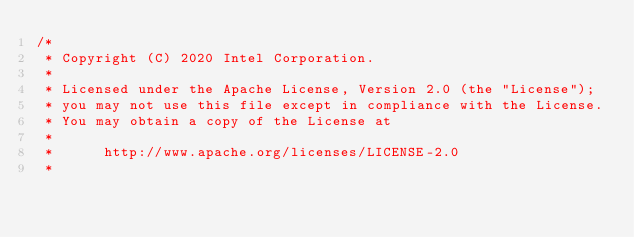<code> <loc_0><loc_0><loc_500><loc_500><_C_>/*
 * Copyright (C) 2020 Intel Corporation.
 *
 * Licensed under the Apache License, Version 2.0 (the "License");
 * you may not use this file except in compliance with the License.
 * You may obtain a copy of the License at
 *
 *      http://www.apache.org/licenses/LICENSE-2.0
 *</code> 